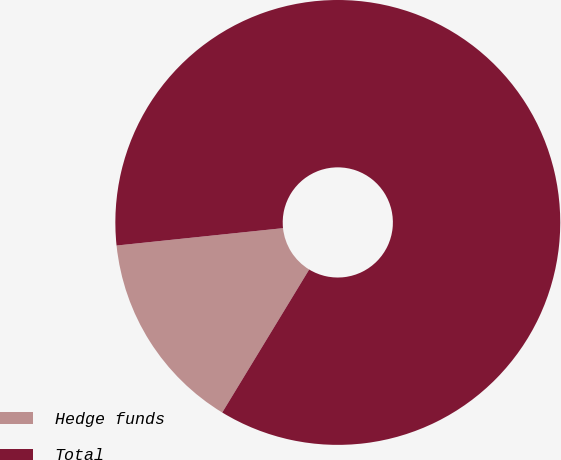<chart> <loc_0><loc_0><loc_500><loc_500><pie_chart><fcel>Hedge funds<fcel>Total<nl><fcel>14.65%<fcel>85.35%<nl></chart> 